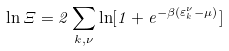Convert formula to latex. <formula><loc_0><loc_0><loc_500><loc_500>\ln \Xi = 2 \sum _ { { k } , \nu } \ln [ 1 + e ^ { - \beta ( \varepsilon _ { k } ^ { \nu } - \mu ) } ]</formula> 